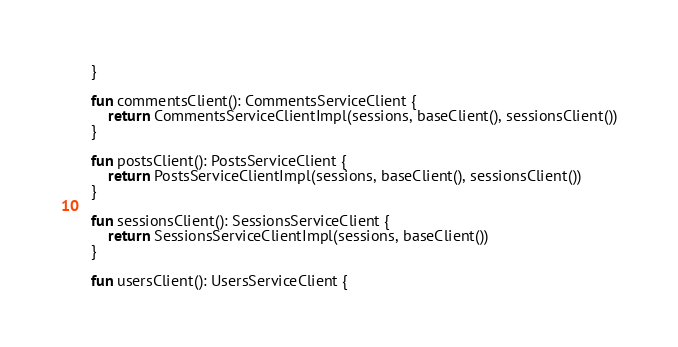Convert code to text. <code><loc_0><loc_0><loc_500><loc_500><_Kotlin_>    }

    fun commentsClient(): CommentsServiceClient {
        return CommentsServiceClientImpl(sessions, baseClient(), sessionsClient())
    }

    fun postsClient(): PostsServiceClient {
        return PostsServiceClientImpl(sessions, baseClient(), sessionsClient())
    }

    fun sessionsClient(): SessionsServiceClient {
        return SessionsServiceClientImpl(sessions, baseClient())
    }

    fun usersClient(): UsersServiceClient {</code> 